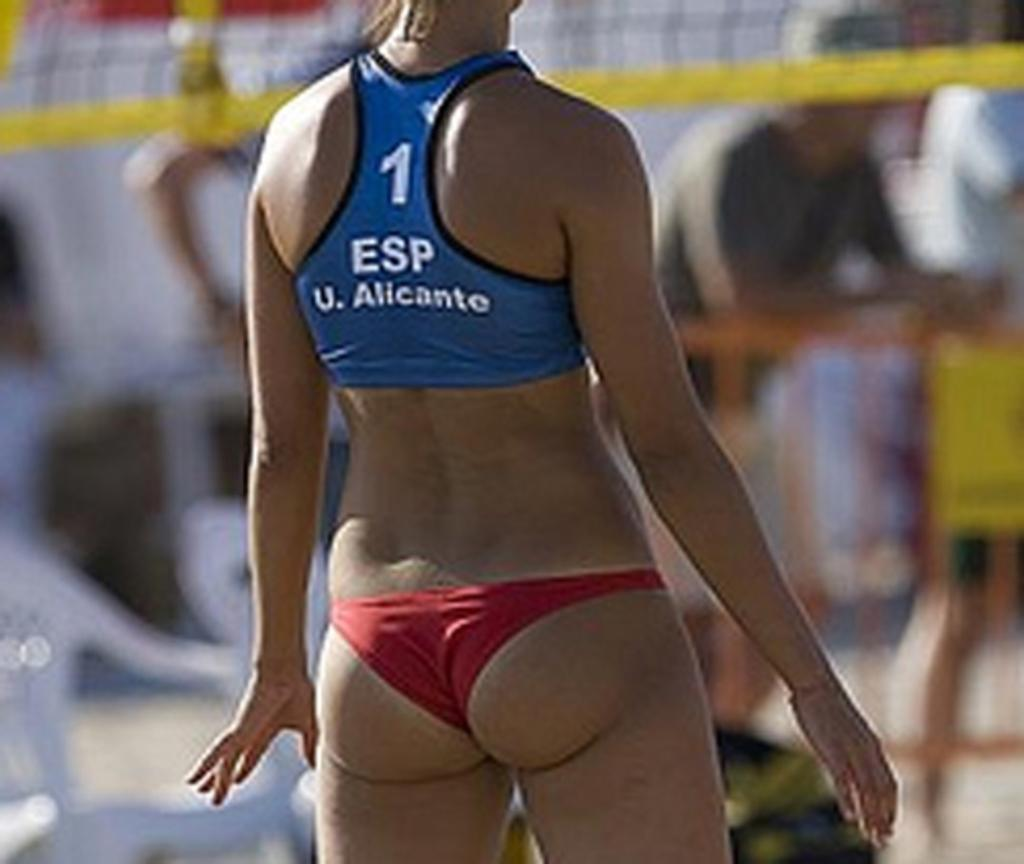<image>
Provide a brief description of the given image. A woman wearing a bikini and it has the digit 1 on the back. 